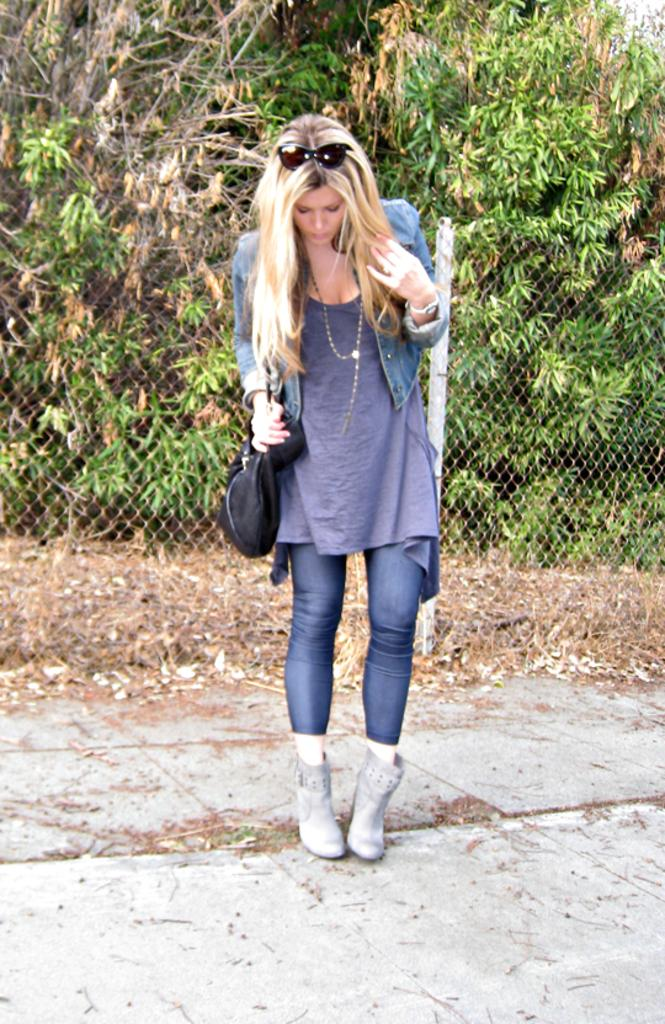Who is the main subject in the image? There is a girl in the image. What is the girl doing in the image? The girl is standing on the ground. What accessories is the girl wearing in the image? The girl is wearing a bag and goggles. What can be seen in the background of the image? There is a fence and trees in the background of the image. What is the girl's reaction to the sudden profit in the image? There is no mention of profit in the image, so it is not possible to determine the girl's reaction to it. 